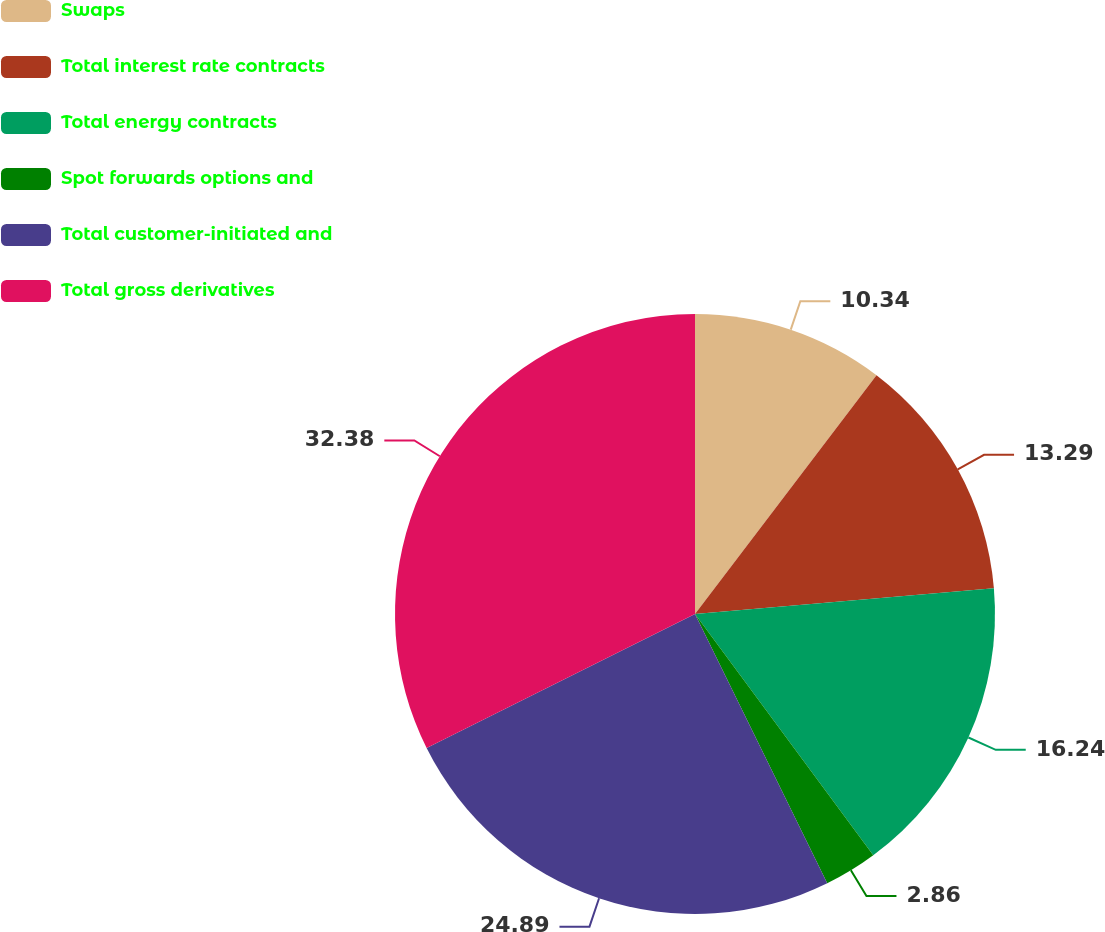Convert chart. <chart><loc_0><loc_0><loc_500><loc_500><pie_chart><fcel>Swaps<fcel>Total interest rate contracts<fcel>Total energy contracts<fcel>Spot forwards options and<fcel>Total customer-initiated and<fcel>Total gross derivatives<nl><fcel>10.34%<fcel>13.29%<fcel>16.24%<fcel>2.86%<fcel>24.89%<fcel>32.37%<nl></chart> 